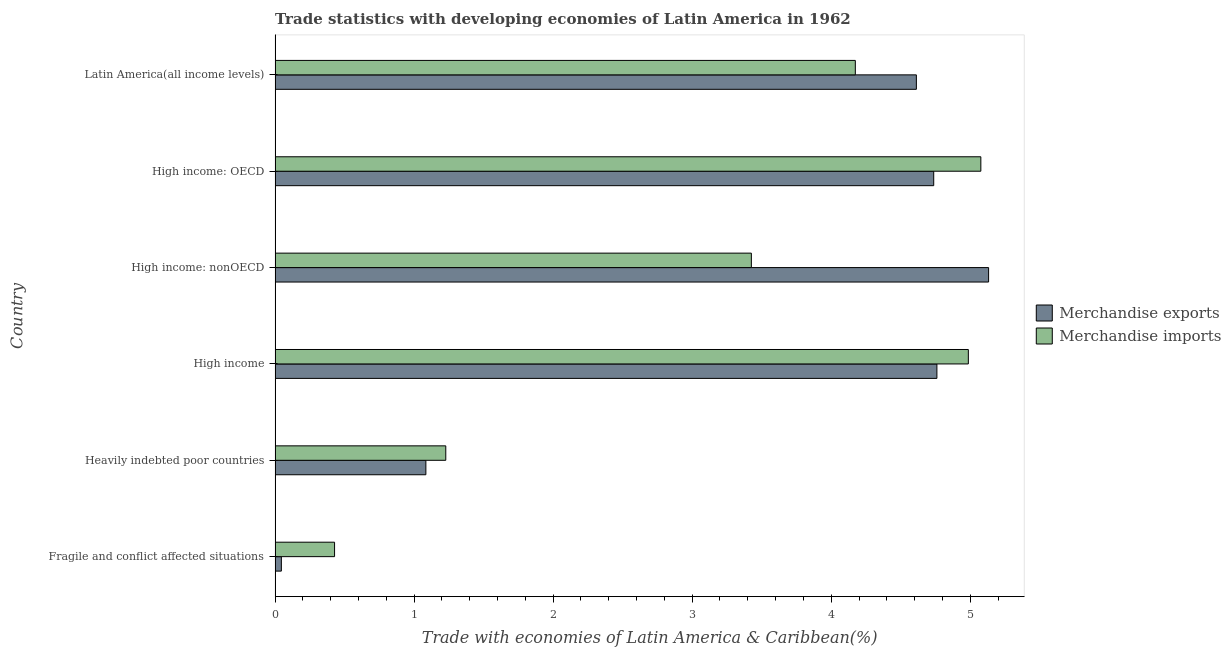Are the number of bars per tick equal to the number of legend labels?
Give a very brief answer. Yes. What is the label of the 5th group of bars from the top?
Ensure brevity in your answer.  Heavily indebted poor countries. In how many cases, is the number of bars for a given country not equal to the number of legend labels?
Offer a terse response. 0. What is the merchandise exports in Latin America(all income levels)?
Offer a terse response. 4.61. Across all countries, what is the maximum merchandise exports?
Give a very brief answer. 5.13. Across all countries, what is the minimum merchandise exports?
Provide a succinct answer. 0.05. In which country was the merchandise exports maximum?
Ensure brevity in your answer.  High income: nonOECD. In which country was the merchandise exports minimum?
Your response must be concise. Fragile and conflict affected situations. What is the total merchandise exports in the graph?
Offer a terse response. 20.37. What is the difference between the merchandise exports in High income: OECD and that in High income: nonOECD?
Ensure brevity in your answer.  -0.4. What is the difference between the merchandise imports in High income and the merchandise exports in Heavily indebted poor countries?
Your response must be concise. 3.9. What is the average merchandise imports per country?
Keep it short and to the point. 3.22. What is the difference between the merchandise imports and merchandise exports in Heavily indebted poor countries?
Ensure brevity in your answer.  0.14. In how many countries, is the merchandise imports greater than 4.2 %?
Ensure brevity in your answer.  2. What is the ratio of the merchandise imports in High income: OECD to that in High income: nonOECD?
Provide a short and direct response. 1.48. What is the difference between the highest and the second highest merchandise exports?
Your answer should be very brief. 0.37. What is the difference between the highest and the lowest merchandise exports?
Your answer should be compact. 5.09. In how many countries, is the merchandise imports greater than the average merchandise imports taken over all countries?
Give a very brief answer. 4. What does the 1st bar from the top in Fragile and conflict affected situations represents?
Offer a very short reply. Merchandise imports. What does the 2nd bar from the bottom in High income represents?
Your answer should be very brief. Merchandise imports. What is the difference between two consecutive major ticks on the X-axis?
Your answer should be compact. 1. Does the graph contain any zero values?
Offer a very short reply. No. How many legend labels are there?
Offer a very short reply. 2. What is the title of the graph?
Offer a very short reply. Trade statistics with developing economies of Latin America in 1962. What is the label or title of the X-axis?
Offer a terse response. Trade with economies of Latin America & Caribbean(%). What is the Trade with economies of Latin America & Caribbean(%) of Merchandise exports in Fragile and conflict affected situations?
Your response must be concise. 0.05. What is the Trade with economies of Latin America & Caribbean(%) in Merchandise imports in Fragile and conflict affected situations?
Keep it short and to the point. 0.43. What is the Trade with economies of Latin America & Caribbean(%) in Merchandise exports in Heavily indebted poor countries?
Your answer should be compact. 1.08. What is the Trade with economies of Latin America & Caribbean(%) of Merchandise imports in Heavily indebted poor countries?
Your answer should be very brief. 1.23. What is the Trade with economies of Latin America & Caribbean(%) in Merchandise exports in High income?
Make the answer very short. 4.76. What is the Trade with economies of Latin America & Caribbean(%) in Merchandise imports in High income?
Give a very brief answer. 4.99. What is the Trade with economies of Latin America & Caribbean(%) in Merchandise exports in High income: nonOECD?
Provide a succinct answer. 5.13. What is the Trade with economies of Latin America & Caribbean(%) of Merchandise imports in High income: nonOECD?
Provide a succinct answer. 3.43. What is the Trade with economies of Latin America & Caribbean(%) in Merchandise exports in High income: OECD?
Your answer should be compact. 4.74. What is the Trade with economies of Latin America & Caribbean(%) in Merchandise imports in High income: OECD?
Offer a very short reply. 5.08. What is the Trade with economies of Latin America & Caribbean(%) in Merchandise exports in Latin America(all income levels)?
Ensure brevity in your answer.  4.61. What is the Trade with economies of Latin America & Caribbean(%) of Merchandise imports in Latin America(all income levels)?
Ensure brevity in your answer.  4.17. Across all countries, what is the maximum Trade with economies of Latin America & Caribbean(%) of Merchandise exports?
Make the answer very short. 5.13. Across all countries, what is the maximum Trade with economies of Latin America & Caribbean(%) of Merchandise imports?
Provide a succinct answer. 5.08. Across all countries, what is the minimum Trade with economies of Latin America & Caribbean(%) of Merchandise exports?
Your answer should be compact. 0.05. Across all countries, what is the minimum Trade with economies of Latin America & Caribbean(%) of Merchandise imports?
Offer a terse response. 0.43. What is the total Trade with economies of Latin America & Caribbean(%) in Merchandise exports in the graph?
Make the answer very short. 20.37. What is the total Trade with economies of Latin America & Caribbean(%) in Merchandise imports in the graph?
Provide a succinct answer. 19.32. What is the difference between the Trade with economies of Latin America & Caribbean(%) in Merchandise exports in Fragile and conflict affected situations and that in Heavily indebted poor countries?
Keep it short and to the point. -1.04. What is the difference between the Trade with economies of Latin America & Caribbean(%) in Merchandise imports in Fragile and conflict affected situations and that in Heavily indebted poor countries?
Provide a succinct answer. -0.8. What is the difference between the Trade with economies of Latin America & Caribbean(%) of Merchandise exports in Fragile and conflict affected situations and that in High income?
Provide a succinct answer. -4.72. What is the difference between the Trade with economies of Latin America & Caribbean(%) in Merchandise imports in Fragile and conflict affected situations and that in High income?
Offer a very short reply. -4.56. What is the difference between the Trade with economies of Latin America & Caribbean(%) of Merchandise exports in Fragile and conflict affected situations and that in High income: nonOECD?
Provide a succinct answer. -5.09. What is the difference between the Trade with economies of Latin America & Caribbean(%) in Merchandise imports in Fragile and conflict affected situations and that in High income: nonOECD?
Provide a succinct answer. -3. What is the difference between the Trade with economies of Latin America & Caribbean(%) in Merchandise exports in Fragile and conflict affected situations and that in High income: OECD?
Offer a very short reply. -4.69. What is the difference between the Trade with economies of Latin America & Caribbean(%) of Merchandise imports in Fragile and conflict affected situations and that in High income: OECD?
Provide a short and direct response. -4.65. What is the difference between the Trade with economies of Latin America & Caribbean(%) of Merchandise exports in Fragile and conflict affected situations and that in Latin America(all income levels)?
Keep it short and to the point. -4.57. What is the difference between the Trade with economies of Latin America & Caribbean(%) of Merchandise imports in Fragile and conflict affected situations and that in Latin America(all income levels)?
Make the answer very short. -3.75. What is the difference between the Trade with economies of Latin America & Caribbean(%) of Merchandise exports in Heavily indebted poor countries and that in High income?
Ensure brevity in your answer.  -3.68. What is the difference between the Trade with economies of Latin America & Caribbean(%) in Merchandise imports in Heavily indebted poor countries and that in High income?
Provide a short and direct response. -3.76. What is the difference between the Trade with economies of Latin America & Caribbean(%) in Merchandise exports in Heavily indebted poor countries and that in High income: nonOECD?
Provide a short and direct response. -4.05. What is the difference between the Trade with economies of Latin America & Caribbean(%) of Merchandise imports in Heavily indebted poor countries and that in High income: nonOECD?
Your response must be concise. -2.2. What is the difference between the Trade with economies of Latin America & Caribbean(%) of Merchandise exports in Heavily indebted poor countries and that in High income: OECD?
Offer a terse response. -3.65. What is the difference between the Trade with economies of Latin America & Caribbean(%) in Merchandise imports in Heavily indebted poor countries and that in High income: OECD?
Keep it short and to the point. -3.85. What is the difference between the Trade with economies of Latin America & Caribbean(%) in Merchandise exports in Heavily indebted poor countries and that in Latin America(all income levels)?
Your answer should be very brief. -3.53. What is the difference between the Trade with economies of Latin America & Caribbean(%) in Merchandise imports in Heavily indebted poor countries and that in Latin America(all income levels)?
Offer a terse response. -2.95. What is the difference between the Trade with economies of Latin America & Caribbean(%) of Merchandise exports in High income and that in High income: nonOECD?
Your response must be concise. -0.37. What is the difference between the Trade with economies of Latin America & Caribbean(%) in Merchandise imports in High income and that in High income: nonOECD?
Give a very brief answer. 1.56. What is the difference between the Trade with economies of Latin America & Caribbean(%) in Merchandise exports in High income and that in High income: OECD?
Your answer should be compact. 0.02. What is the difference between the Trade with economies of Latin America & Caribbean(%) of Merchandise imports in High income and that in High income: OECD?
Offer a very short reply. -0.09. What is the difference between the Trade with economies of Latin America & Caribbean(%) of Merchandise exports in High income and that in Latin America(all income levels)?
Your response must be concise. 0.15. What is the difference between the Trade with economies of Latin America & Caribbean(%) of Merchandise imports in High income and that in Latin America(all income levels)?
Ensure brevity in your answer.  0.81. What is the difference between the Trade with economies of Latin America & Caribbean(%) of Merchandise exports in High income: nonOECD and that in High income: OECD?
Provide a short and direct response. 0.39. What is the difference between the Trade with economies of Latin America & Caribbean(%) in Merchandise imports in High income: nonOECD and that in High income: OECD?
Keep it short and to the point. -1.65. What is the difference between the Trade with economies of Latin America & Caribbean(%) in Merchandise exports in High income: nonOECD and that in Latin America(all income levels)?
Provide a short and direct response. 0.52. What is the difference between the Trade with economies of Latin America & Caribbean(%) in Merchandise imports in High income: nonOECD and that in Latin America(all income levels)?
Offer a terse response. -0.75. What is the difference between the Trade with economies of Latin America & Caribbean(%) in Merchandise exports in High income: OECD and that in Latin America(all income levels)?
Your answer should be compact. 0.12. What is the difference between the Trade with economies of Latin America & Caribbean(%) in Merchandise imports in High income: OECD and that in Latin America(all income levels)?
Your answer should be very brief. 0.9. What is the difference between the Trade with economies of Latin America & Caribbean(%) in Merchandise exports in Fragile and conflict affected situations and the Trade with economies of Latin America & Caribbean(%) in Merchandise imports in Heavily indebted poor countries?
Offer a very short reply. -1.18. What is the difference between the Trade with economies of Latin America & Caribbean(%) in Merchandise exports in Fragile and conflict affected situations and the Trade with economies of Latin America & Caribbean(%) in Merchandise imports in High income?
Keep it short and to the point. -4.94. What is the difference between the Trade with economies of Latin America & Caribbean(%) in Merchandise exports in Fragile and conflict affected situations and the Trade with economies of Latin America & Caribbean(%) in Merchandise imports in High income: nonOECD?
Your answer should be compact. -3.38. What is the difference between the Trade with economies of Latin America & Caribbean(%) in Merchandise exports in Fragile and conflict affected situations and the Trade with economies of Latin America & Caribbean(%) in Merchandise imports in High income: OECD?
Provide a short and direct response. -5.03. What is the difference between the Trade with economies of Latin America & Caribbean(%) in Merchandise exports in Fragile and conflict affected situations and the Trade with economies of Latin America & Caribbean(%) in Merchandise imports in Latin America(all income levels)?
Provide a succinct answer. -4.13. What is the difference between the Trade with economies of Latin America & Caribbean(%) of Merchandise exports in Heavily indebted poor countries and the Trade with economies of Latin America & Caribbean(%) of Merchandise imports in High income?
Make the answer very short. -3.9. What is the difference between the Trade with economies of Latin America & Caribbean(%) in Merchandise exports in Heavily indebted poor countries and the Trade with economies of Latin America & Caribbean(%) in Merchandise imports in High income: nonOECD?
Offer a very short reply. -2.34. What is the difference between the Trade with economies of Latin America & Caribbean(%) of Merchandise exports in Heavily indebted poor countries and the Trade with economies of Latin America & Caribbean(%) of Merchandise imports in High income: OECD?
Give a very brief answer. -3.99. What is the difference between the Trade with economies of Latin America & Caribbean(%) of Merchandise exports in Heavily indebted poor countries and the Trade with economies of Latin America & Caribbean(%) of Merchandise imports in Latin America(all income levels)?
Make the answer very short. -3.09. What is the difference between the Trade with economies of Latin America & Caribbean(%) in Merchandise exports in High income and the Trade with economies of Latin America & Caribbean(%) in Merchandise imports in High income: nonOECD?
Provide a succinct answer. 1.33. What is the difference between the Trade with economies of Latin America & Caribbean(%) in Merchandise exports in High income and the Trade with economies of Latin America & Caribbean(%) in Merchandise imports in High income: OECD?
Give a very brief answer. -0.32. What is the difference between the Trade with economies of Latin America & Caribbean(%) in Merchandise exports in High income and the Trade with economies of Latin America & Caribbean(%) in Merchandise imports in Latin America(all income levels)?
Offer a very short reply. 0.59. What is the difference between the Trade with economies of Latin America & Caribbean(%) of Merchandise exports in High income: nonOECD and the Trade with economies of Latin America & Caribbean(%) of Merchandise imports in High income: OECD?
Offer a very short reply. 0.06. What is the difference between the Trade with economies of Latin America & Caribbean(%) of Merchandise exports in High income: nonOECD and the Trade with economies of Latin America & Caribbean(%) of Merchandise imports in Latin America(all income levels)?
Provide a short and direct response. 0.96. What is the difference between the Trade with economies of Latin America & Caribbean(%) of Merchandise exports in High income: OECD and the Trade with economies of Latin America & Caribbean(%) of Merchandise imports in Latin America(all income levels)?
Provide a short and direct response. 0.56. What is the average Trade with economies of Latin America & Caribbean(%) of Merchandise exports per country?
Offer a very short reply. 3.4. What is the average Trade with economies of Latin America & Caribbean(%) in Merchandise imports per country?
Provide a short and direct response. 3.22. What is the difference between the Trade with economies of Latin America & Caribbean(%) in Merchandise exports and Trade with economies of Latin America & Caribbean(%) in Merchandise imports in Fragile and conflict affected situations?
Keep it short and to the point. -0.38. What is the difference between the Trade with economies of Latin America & Caribbean(%) of Merchandise exports and Trade with economies of Latin America & Caribbean(%) of Merchandise imports in Heavily indebted poor countries?
Your response must be concise. -0.14. What is the difference between the Trade with economies of Latin America & Caribbean(%) of Merchandise exports and Trade with economies of Latin America & Caribbean(%) of Merchandise imports in High income?
Your response must be concise. -0.23. What is the difference between the Trade with economies of Latin America & Caribbean(%) of Merchandise exports and Trade with economies of Latin America & Caribbean(%) of Merchandise imports in High income: nonOECD?
Provide a succinct answer. 1.71. What is the difference between the Trade with economies of Latin America & Caribbean(%) in Merchandise exports and Trade with economies of Latin America & Caribbean(%) in Merchandise imports in High income: OECD?
Your answer should be compact. -0.34. What is the difference between the Trade with economies of Latin America & Caribbean(%) in Merchandise exports and Trade with economies of Latin America & Caribbean(%) in Merchandise imports in Latin America(all income levels)?
Ensure brevity in your answer.  0.44. What is the ratio of the Trade with economies of Latin America & Caribbean(%) of Merchandise exports in Fragile and conflict affected situations to that in Heavily indebted poor countries?
Your response must be concise. 0.04. What is the ratio of the Trade with economies of Latin America & Caribbean(%) in Merchandise imports in Fragile and conflict affected situations to that in Heavily indebted poor countries?
Your response must be concise. 0.35. What is the ratio of the Trade with economies of Latin America & Caribbean(%) of Merchandise exports in Fragile and conflict affected situations to that in High income?
Your answer should be very brief. 0.01. What is the ratio of the Trade with economies of Latin America & Caribbean(%) of Merchandise imports in Fragile and conflict affected situations to that in High income?
Make the answer very short. 0.09. What is the ratio of the Trade with economies of Latin America & Caribbean(%) in Merchandise exports in Fragile and conflict affected situations to that in High income: nonOECD?
Offer a terse response. 0.01. What is the ratio of the Trade with economies of Latin America & Caribbean(%) of Merchandise imports in Fragile and conflict affected situations to that in High income: nonOECD?
Your answer should be very brief. 0.12. What is the ratio of the Trade with economies of Latin America & Caribbean(%) in Merchandise exports in Fragile and conflict affected situations to that in High income: OECD?
Provide a succinct answer. 0.01. What is the ratio of the Trade with economies of Latin America & Caribbean(%) in Merchandise imports in Fragile and conflict affected situations to that in High income: OECD?
Provide a short and direct response. 0.08. What is the ratio of the Trade with economies of Latin America & Caribbean(%) of Merchandise exports in Fragile and conflict affected situations to that in Latin America(all income levels)?
Keep it short and to the point. 0.01. What is the ratio of the Trade with economies of Latin America & Caribbean(%) of Merchandise imports in Fragile and conflict affected situations to that in Latin America(all income levels)?
Provide a succinct answer. 0.1. What is the ratio of the Trade with economies of Latin America & Caribbean(%) in Merchandise exports in Heavily indebted poor countries to that in High income?
Keep it short and to the point. 0.23. What is the ratio of the Trade with economies of Latin America & Caribbean(%) of Merchandise imports in Heavily indebted poor countries to that in High income?
Give a very brief answer. 0.25. What is the ratio of the Trade with economies of Latin America & Caribbean(%) of Merchandise exports in Heavily indebted poor countries to that in High income: nonOECD?
Your response must be concise. 0.21. What is the ratio of the Trade with economies of Latin America & Caribbean(%) in Merchandise imports in Heavily indebted poor countries to that in High income: nonOECD?
Your answer should be compact. 0.36. What is the ratio of the Trade with economies of Latin America & Caribbean(%) of Merchandise exports in Heavily indebted poor countries to that in High income: OECD?
Your answer should be very brief. 0.23. What is the ratio of the Trade with economies of Latin America & Caribbean(%) in Merchandise imports in Heavily indebted poor countries to that in High income: OECD?
Your answer should be very brief. 0.24. What is the ratio of the Trade with economies of Latin America & Caribbean(%) in Merchandise exports in Heavily indebted poor countries to that in Latin America(all income levels)?
Offer a terse response. 0.24. What is the ratio of the Trade with economies of Latin America & Caribbean(%) in Merchandise imports in Heavily indebted poor countries to that in Latin America(all income levels)?
Your answer should be very brief. 0.29. What is the ratio of the Trade with economies of Latin America & Caribbean(%) in Merchandise exports in High income to that in High income: nonOECD?
Give a very brief answer. 0.93. What is the ratio of the Trade with economies of Latin America & Caribbean(%) of Merchandise imports in High income to that in High income: nonOECD?
Give a very brief answer. 1.46. What is the ratio of the Trade with economies of Latin America & Caribbean(%) of Merchandise imports in High income to that in High income: OECD?
Offer a terse response. 0.98. What is the ratio of the Trade with economies of Latin America & Caribbean(%) of Merchandise exports in High income to that in Latin America(all income levels)?
Your response must be concise. 1.03. What is the ratio of the Trade with economies of Latin America & Caribbean(%) in Merchandise imports in High income to that in Latin America(all income levels)?
Offer a terse response. 1.19. What is the ratio of the Trade with economies of Latin America & Caribbean(%) of Merchandise imports in High income: nonOECD to that in High income: OECD?
Offer a very short reply. 0.67. What is the ratio of the Trade with economies of Latin America & Caribbean(%) in Merchandise exports in High income: nonOECD to that in Latin America(all income levels)?
Your response must be concise. 1.11. What is the ratio of the Trade with economies of Latin America & Caribbean(%) in Merchandise imports in High income: nonOECD to that in Latin America(all income levels)?
Your answer should be very brief. 0.82. What is the ratio of the Trade with economies of Latin America & Caribbean(%) in Merchandise imports in High income: OECD to that in Latin America(all income levels)?
Provide a short and direct response. 1.22. What is the difference between the highest and the second highest Trade with economies of Latin America & Caribbean(%) in Merchandise exports?
Make the answer very short. 0.37. What is the difference between the highest and the second highest Trade with economies of Latin America & Caribbean(%) of Merchandise imports?
Your answer should be compact. 0.09. What is the difference between the highest and the lowest Trade with economies of Latin America & Caribbean(%) of Merchandise exports?
Provide a short and direct response. 5.09. What is the difference between the highest and the lowest Trade with economies of Latin America & Caribbean(%) in Merchandise imports?
Keep it short and to the point. 4.65. 